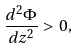Convert formula to latex. <formula><loc_0><loc_0><loc_500><loc_500>\frac { d ^ { 2 } \Phi } { d z ^ { 2 } } > 0 ,</formula> 